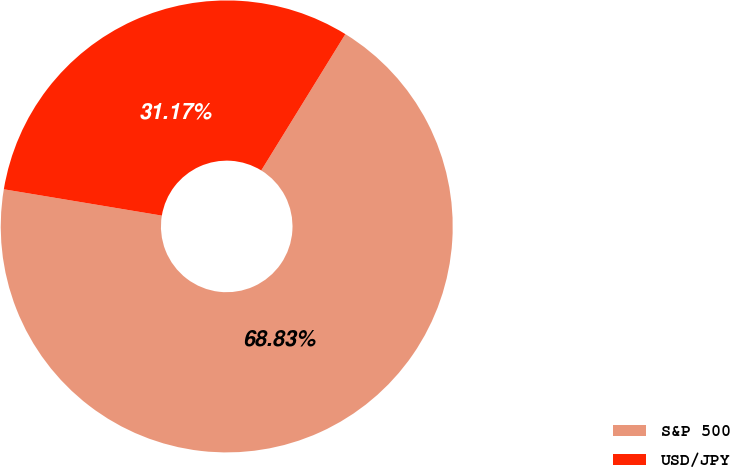<chart> <loc_0><loc_0><loc_500><loc_500><pie_chart><fcel>S&P 500<fcel>USD/JPY<nl><fcel>68.83%<fcel>31.17%<nl></chart> 